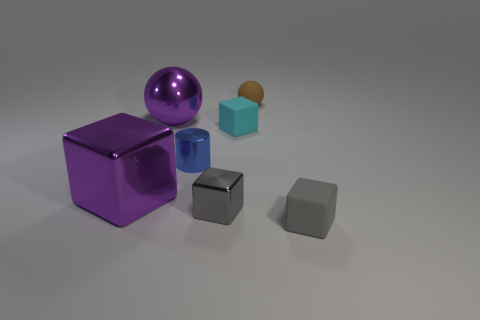Add 3 large shiny objects. How many objects exist? 10 Subtract all cubes. How many objects are left? 3 Add 6 tiny rubber cubes. How many tiny rubber cubes exist? 8 Subtract 0 gray cylinders. How many objects are left? 7 Subtract all tiny green cylinders. Subtract all matte balls. How many objects are left? 6 Add 6 small cyan matte cubes. How many small cyan matte cubes are left? 7 